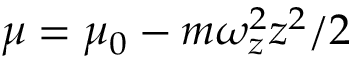Convert formula to latex. <formula><loc_0><loc_0><loc_500><loc_500>\mu = \mu _ { 0 } - m \omega _ { z } ^ { 2 } z ^ { 2 } / 2</formula> 